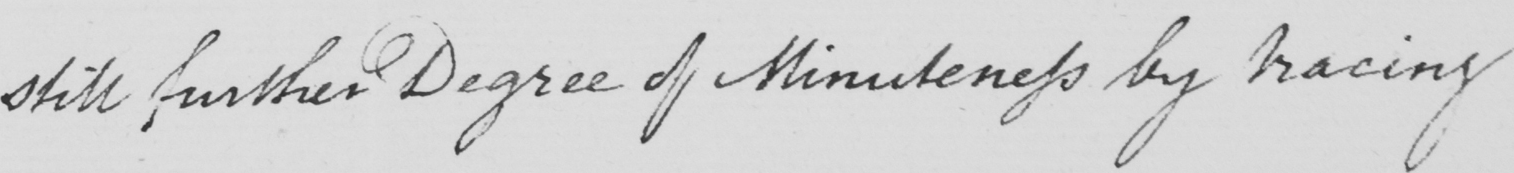What is written in this line of handwriting? still further Degree of Minuteness by tracing 